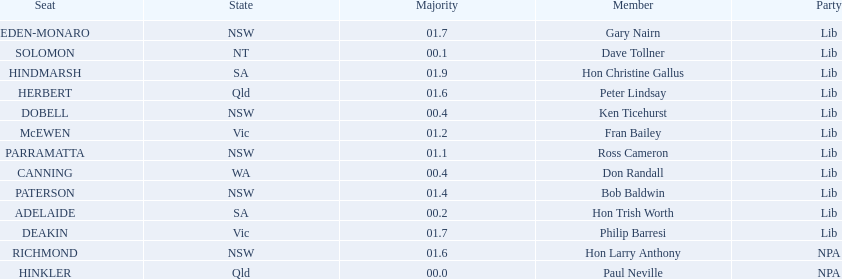Which seats are represented in the electoral system of australia? HINKLER, SOLOMON, ADELAIDE, CANNING, DOBELL, PARRAMATTA, McEWEN, PATERSON, HERBERT, RICHMOND, DEAKIN, EDEN-MONARO, HINDMARSH. What were their majority numbers of both hindmarsh and hinkler? HINKLER, HINDMARSH. Of those two seats, what is the difference in voting majority? 01.9. 